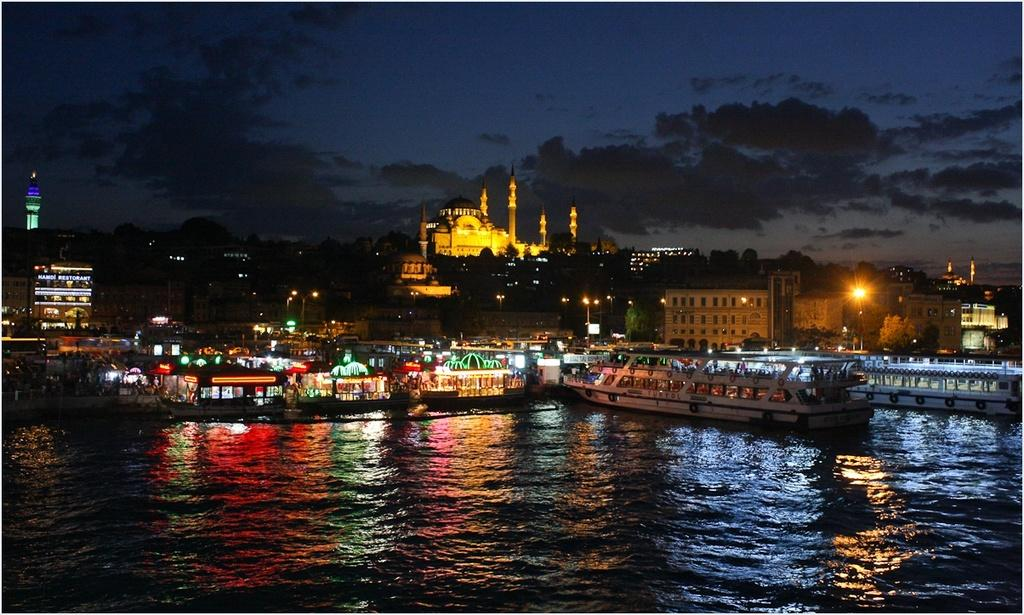What is at the bottom of the image? There is water at the bottom of the image. What is floating on the water? There are boats in the water. What structures are present in the image? Light poles, buildings, and a mosque are visible in the image. What type of vegetation is present in the image? Trees are present in the image. What tall structures are visible in the image? Towers are visible in the image. What is visible at the top of the image? The sky is visible at the top of the image. When was the image taken? The image was taken during nighttime. What type of cloth is draped over the tiger in the image? There is no tiger or cloth present in the image. What type of table is visible in the image? There is no table present in the image. 